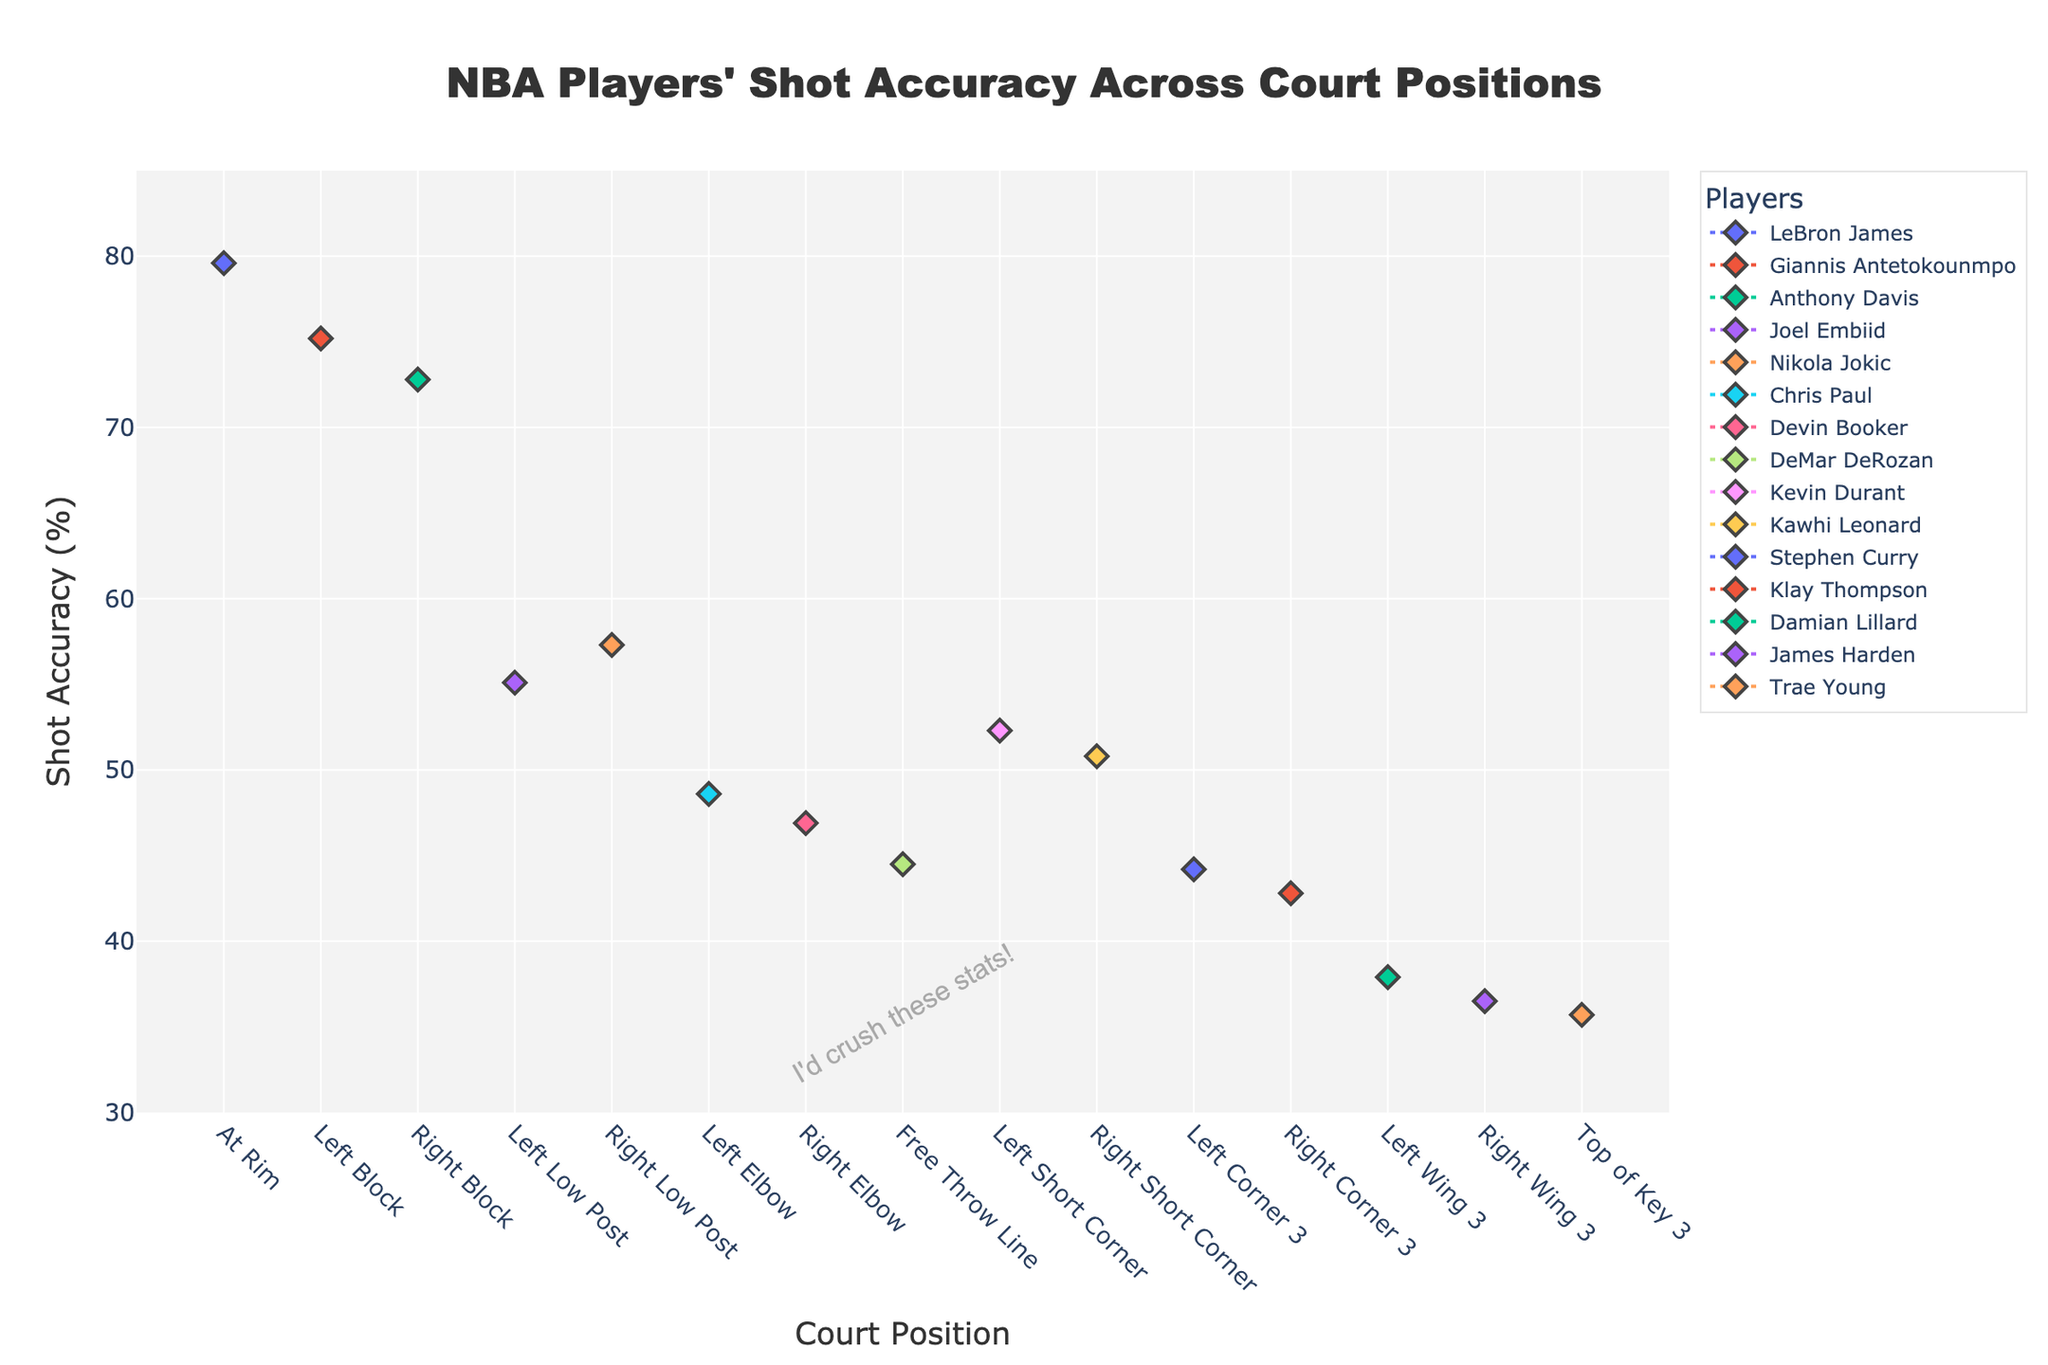Which player has the highest shot accuracy at the rim? To find out which player has the highest shot accuracy at the rim, look for the data point labelled 'At Rim' on the X-axis and then check the player with the highest shot accuracy on the Y-axis. LeBron James has the highest shot accuracy at the rim with 79.6%.
Answer: LeBron James What's the overall trend of shot accuracy as the distance from the basket increases? Observe the plot from left to right, starting from 'At Rim' to 'Left Corner 3', and note the general direction of the accuracy values. Shot accuracy generally decreases as the distance from the basket increases.
Answer: Decreases Compare the shot accuracy of Stephen Curry and Klay Thompson from the corner 3 positions. Who is more accurate? Look at 'Left Corner 3' for Stephen Curry and 'Right Corner 3' for Klay Thompson, then compare their shot accuracy values. Stephen Curry's accuracy is 44.2%, while Klay Thompson's is 42.8%. Stephen Curry is more accurate from the corner 3 positions.
Answer: Stephen Curry Which court position has the largest shot accuracy difference between the two players compared? Check each court position for the maximum difference in shot accuracy between the two compared players. For 'At Rim,' LeBron James has 79.6%, significantly more than the other players at this position, and the closest player is Giannis Antetokounmpo with 75.2% having the largest single gap.
Answer: At Rim For how many positions does Kevin Durant have the highest accuracy compared to other players' data points? Scan through all positions to see how many times Kevin Durant has the highest shot accuracy. Kevin Durant has the highest shot accuracy at 'Left Short Corner' (52.3%).
Answer: One Between the left and right low post positions, who has the better accuracy and by what margin? Compare the shot accuracy at 'Left Low Post' (Joel Embiid's 55.1%) and 'Right Low Post' (Nikola Jokic's 57.3%). Nikola Jokic has a better accuracy by 2.2%.
Answer: Nikola Jokic by 2.2% Who has the lowest shot accuracy from the top of the key 3-point position? Identify the data point for 'Top of Key 3' on the X-axis and then find which player's shot accuracy is plotted here. Trae Young has the lowest shot accuracy from the top of the key at 35.7%.
Answer: Trae Young If you only consider shots taken from 3-point range, who is the most accurate? Look at 3-point range positions ('Left Corner 3,' 'Right Corner 3,' 'Left Wing 3,' 'Right Wing 3,' 'Top of Key 3') and compare the shot accuracy of players. Stephen Curry's 44.2% at 'Left Corner 3' is the highest.
Answer: Stephen Curry What insight can be drawn about Chris Paul's mid-range shot accuracy compared to Devin Booker's? Compare their shots from mid-range positions on the x-axis: both 'Left Elbow' and 'Right Elbow' for Chris Paul (48.6%) and Devin Booker (46.9%). Chris Paul is slightly more accurate than Devin Booker for mid-range shots.
Answer: Chris Paul is more accurate in mid-range 